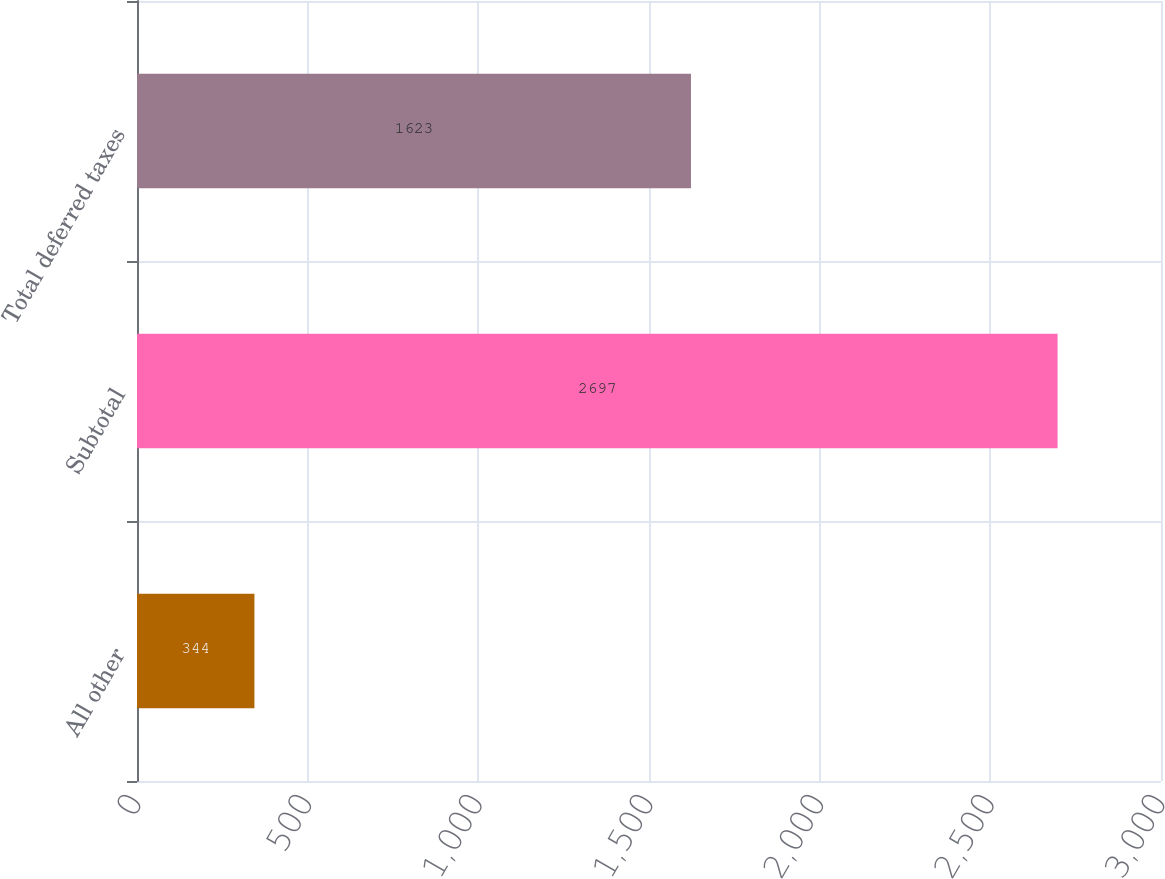<chart> <loc_0><loc_0><loc_500><loc_500><bar_chart><fcel>All other<fcel>Subtotal<fcel>Total deferred taxes<nl><fcel>344<fcel>2697<fcel>1623<nl></chart> 